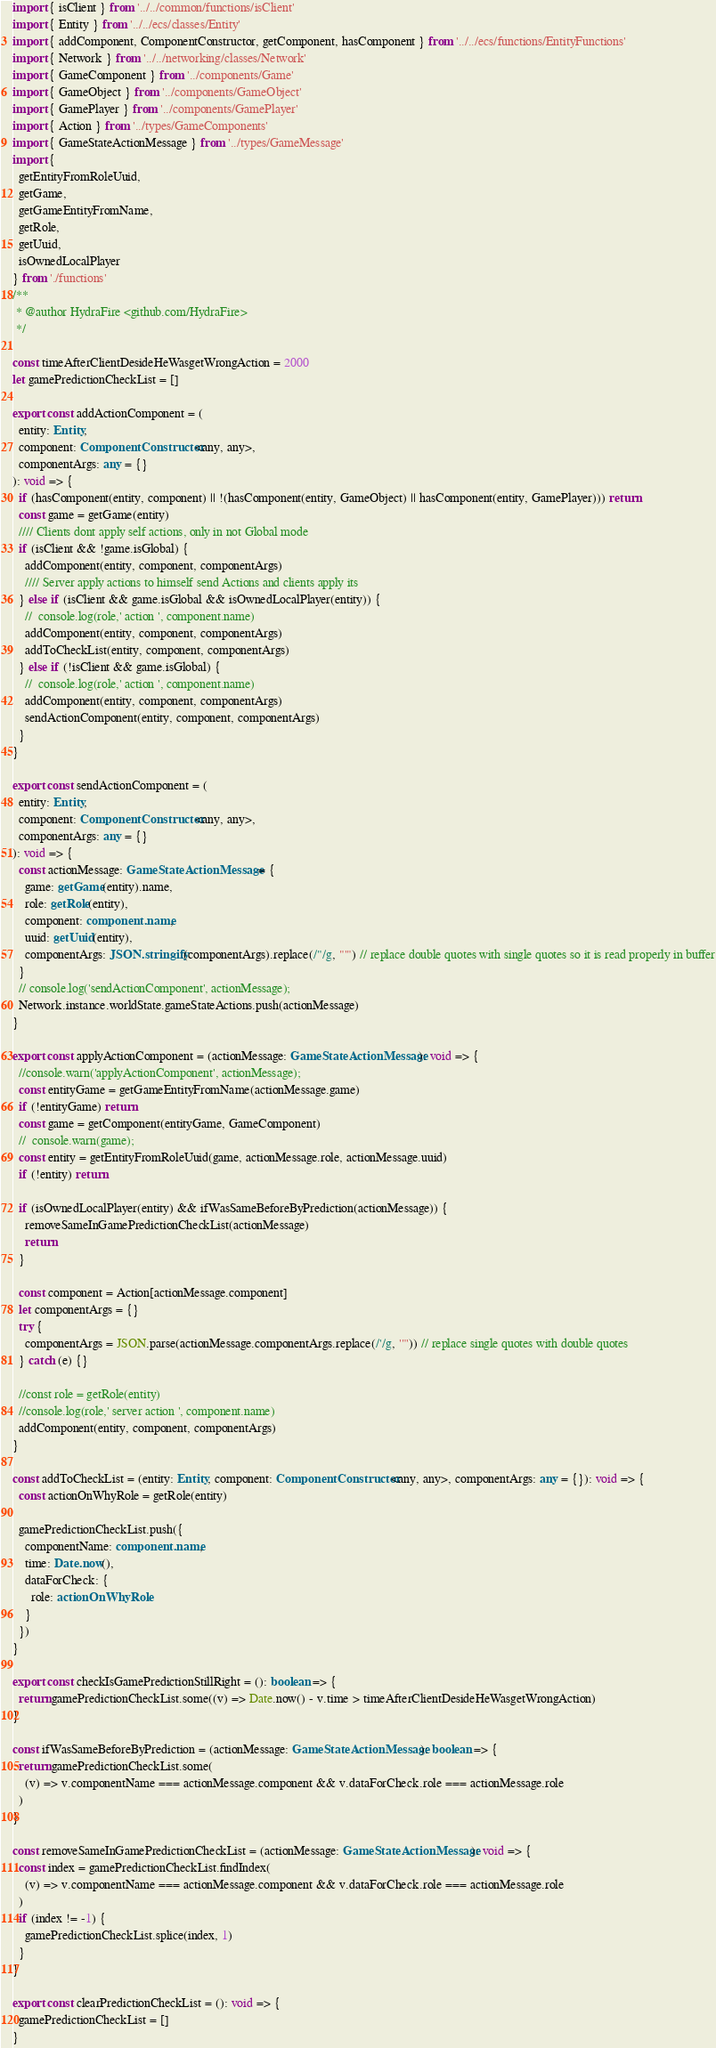Convert code to text. <code><loc_0><loc_0><loc_500><loc_500><_TypeScript_>import { isClient } from '../../common/functions/isClient'
import { Entity } from '../../ecs/classes/Entity'
import { addComponent, ComponentConstructor, getComponent, hasComponent } from '../../ecs/functions/EntityFunctions'
import { Network } from '../../networking/classes/Network'
import { GameComponent } from '../components/Game'
import { GameObject } from '../components/GameObject'
import { GamePlayer } from '../components/GamePlayer'
import { Action } from '../types/GameComponents'
import { GameStateActionMessage } from '../types/GameMessage'
import {
  getEntityFromRoleUuid,
  getGame,
  getGameEntityFromName,
  getRole,
  getUuid,
  isOwnedLocalPlayer
} from './functions'
/**
 * @author HydraFire <github.com/HydraFire>
 */

const timeAfterClientDesideHeWasgetWrongAction = 2000
let gamePredictionCheckList = []

export const addActionComponent = (
  entity: Entity,
  component: ComponentConstructor<any, any>,
  componentArgs: any = {}
): void => {
  if (hasComponent(entity, component) || !(hasComponent(entity, GameObject) || hasComponent(entity, GamePlayer))) return
  const game = getGame(entity)
  //// Clients dont apply self actions, only in not Global mode
  if (isClient && !game.isGlobal) {
    addComponent(entity, component, componentArgs)
    //// Server apply actions to himself send Actions and clients apply its
  } else if (isClient && game.isGlobal && isOwnedLocalPlayer(entity)) {
    //  console.log(role,' action ', component.name)
    addComponent(entity, component, componentArgs)
    addToCheckList(entity, component, componentArgs)
  } else if (!isClient && game.isGlobal) {
    //  console.log(role,' action ', component.name)
    addComponent(entity, component, componentArgs)
    sendActionComponent(entity, component, componentArgs)
  }
}

export const sendActionComponent = (
  entity: Entity,
  component: ComponentConstructor<any, any>,
  componentArgs: any = {}
): void => {
  const actionMessage: GameStateActionMessage = {
    game: getGame(entity).name,
    role: getRole(entity),
    component: component.name,
    uuid: getUuid(entity),
    componentArgs: JSON.stringify(componentArgs).replace(/"/g, "'") // replace double quotes with single quotes so it is read properly in buffer
  }
  // console.log('sendActionComponent', actionMessage);
  Network.instance.worldState.gameStateActions.push(actionMessage)
}

export const applyActionComponent = (actionMessage: GameStateActionMessage): void => {
  //console.warn('applyActionComponent', actionMessage);
  const entityGame = getGameEntityFromName(actionMessage.game)
  if (!entityGame) return
  const game = getComponent(entityGame, GameComponent)
  //  console.warn(game);
  const entity = getEntityFromRoleUuid(game, actionMessage.role, actionMessage.uuid)
  if (!entity) return

  if (isOwnedLocalPlayer(entity) && ifWasSameBeforeByPrediction(actionMessage)) {
    removeSameInGamePredictionCheckList(actionMessage)
    return
  }

  const component = Action[actionMessage.component]
  let componentArgs = {}
  try {
    componentArgs = JSON.parse(actionMessage.componentArgs.replace(/'/g, '"')) // replace single quotes with double quotes
  } catch (e) {}

  //const role = getRole(entity)
  //console.log(role,' server action ', component.name)
  addComponent(entity, component, componentArgs)
}

const addToCheckList = (entity: Entity, component: ComponentConstructor<any, any>, componentArgs: any = {}): void => {
  const actionOnWhyRole = getRole(entity)

  gamePredictionCheckList.push({
    componentName: component.name,
    time: Date.now(),
    dataForCheck: {
      role: actionOnWhyRole
    }
  })
}

export const checkIsGamePredictionStillRight = (): boolean => {
  return gamePredictionCheckList.some((v) => Date.now() - v.time > timeAfterClientDesideHeWasgetWrongAction)
}

const ifWasSameBeforeByPrediction = (actionMessage: GameStateActionMessage): boolean => {
  return gamePredictionCheckList.some(
    (v) => v.componentName === actionMessage.component && v.dataForCheck.role === actionMessage.role
  )
}

const removeSameInGamePredictionCheckList = (actionMessage: GameStateActionMessage): void => {
  const index = gamePredictionCheckList.findIndex(
    (v) => v.componentName === actionMessage.component && v.dataForCheck.role === actionMessage.role
  )
  if (index != -1) {
    gamePredictionCheckList.splice(index, 1)
  }
}

export const clearPredictionCheckList = (): void => {
  gamePredictionCheckList = []
}
</code> 